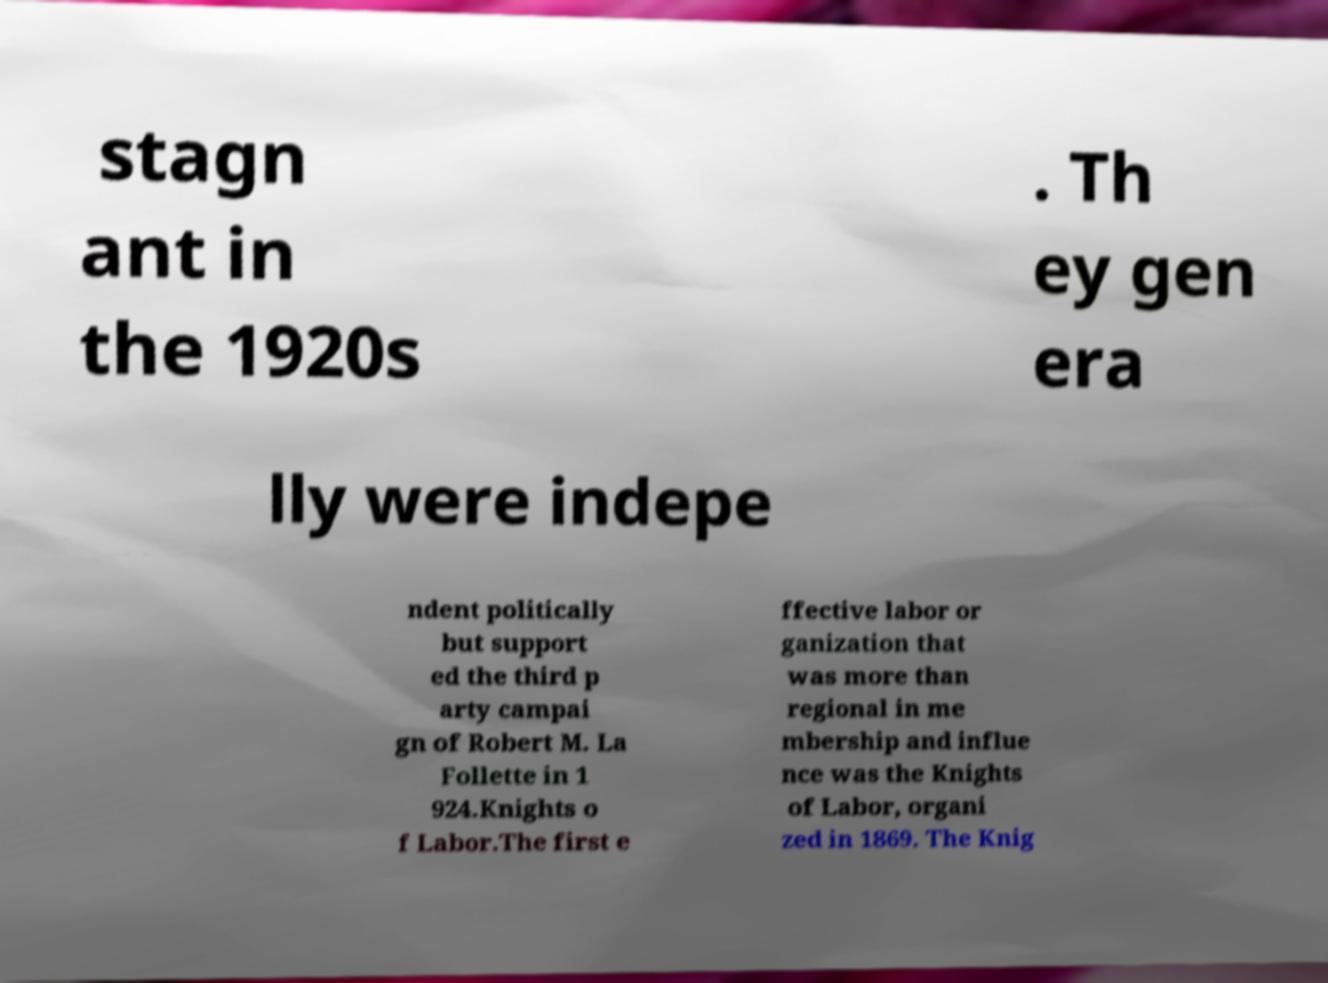Could you extract and type out the text from this image? stagn ant in the 1920s . Th ey gen era lly were indepe ndent politically but support ed the third p arty campai gn of Robert M. La Follette in 1 924.Knights o f Labor.The first e ffective labor or ganization that was more than regional in me mbership and influe nce was the Knights of Labor, organi zed in 1869. The Knig 